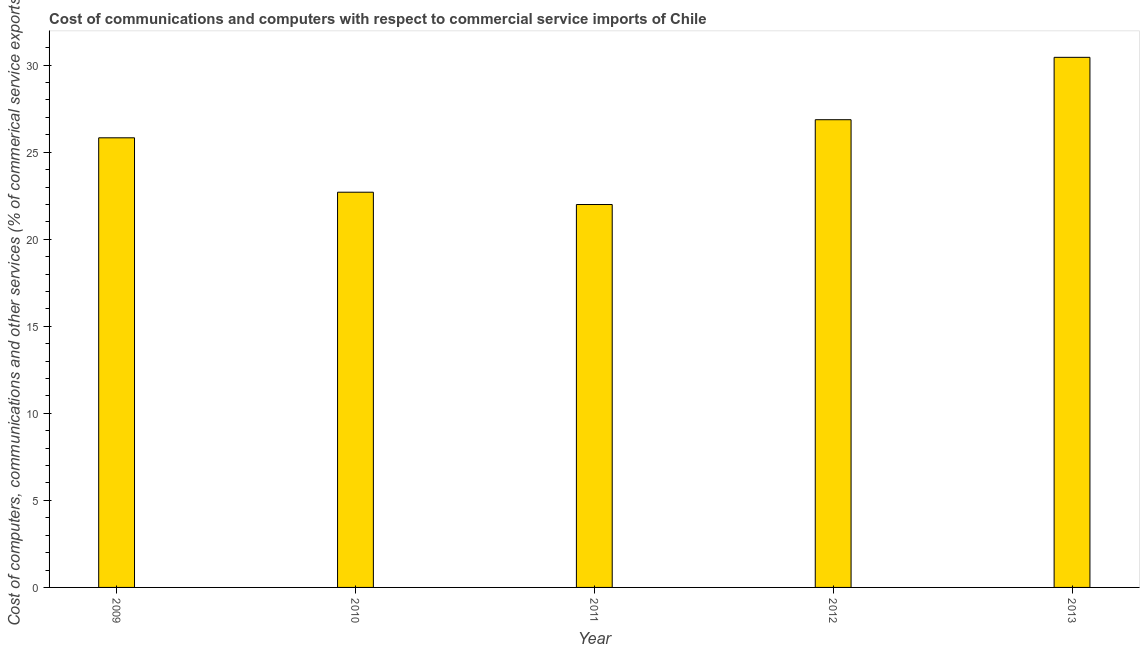Does the graph contain any zero values?
Provide a short and direct response. No. What is the title of the graph?
Ensure brevity in your answer.  Cost of communications and computers with respect to commercial service imports of Chile. What is the label or title of the Y-axis?
Keep it short and to the point. Cost of computers, communications and other services (% of commerical service exports). What is the cost of communications in 2013?
Ensure brevity in your answer.  30.45. Across all years, what is the maximum  computer and other services?
Offer a very short reply. 30.45. Across all years, what is the minimum  computer and other services?
Offer a very short reply. 21.99. In which year was the cost of communications minimum?
Provide a short and direct response. 2011. What is the sum of the  computer and other services?
Offer a terse response. 127.83. What is the difference between the  computer and other services in 2009 and 2012?
Keep it short and to the point. -1.04. What is the average  computer and other services per year?
Provide a short and direct response. 25.57. What is the median  computer and other services?
Provide a succinct answer. 25.83. Do a majority of the years between 2009 and 2010 (inclusive) have cost of communications greater than 26 %?
Ensure brevity in your answer.  No. What is the ratio of the  computer and other services in 2009 to that in 2013?
Provide a short and direct response. 0.85. Is the  computer and other services in 2010 less than that in 2012?
Your answer should be compact. Yes. Is the difference between the cost of communications in 2009 and 2010 greater than the difference between any two years?
Your response must be concise. No. What is the difference between the highest and the second highest  computer and other services?
Ensure brevity in your answer.  3.58. Is the sum of the cost of communications in 2010 and 2011 greater than the maximum cost of communications across all years?
Provide a succinct answer. Yes. What is the difference between the highest and the lowest cost of communications?
Your answer should be compact. 8.45. How many bars are there?
Provide a short and direct response. 5. Are all the bars in the graph horizontal?
Provide a succinct answer. No. How many years are there in the graph?
Make the answer very short. 5. What is the Cost of computers, communications and other services (% of commerical service exports) in 2009?
Provide a short and direct response. 25.83. What is the Cost of computers, communications and other services (% of commerical service exports) of 2010?
Your response must be concise. 22.7. What is the Cost of computers, communications and other services (% of commerical service exports) of 2011?
Offer a terse response. 21.99. What is the Cost of computers, communications and other services (% of commerical service exports) in 2012?
Provide a short and direct response. 26.87. What is the Cost of computers, communications and other services (% of commerical service exports) in 2013?
Give a very brief answer. 30.45. What is the difference between the Cost of computers, communications and other services (% of commerical service exports) in 2009 and 2010?
Provide a succinct answer. 3.12. What is the difference between the Cost of computers, communications and other services (% of commerical service exports) in 2009 and 2011?
Provide a succinct answer. 3.83. What is the difference between the Cost of computers, communications and other services (% of commerical service exports) in 2009 and 2012?
Give a very brief answer. -1.04. What is the difference between the Cost of computers, communications and other services (% of commerical service exports) in 2009 and 2013?
Your response must be concise. -4.62. What is the difference between the Cost of computers, communications and other services (% of commerical service exports) in 2010 and 2011?
Your answer should be compact. 0.71. What is the difference between the Cost of computers, communications and other services (% of commerical service exports) in 2010 and 2012?
Keep it short and to the point. -4.16. What is the difference between the Cost of computers, communications and other services (% of commerical service exports) in 2010 and 2013?
Provide a succinct answer. -7.75. What is the difference between the Cost of computers, communications and other services (% of commerical service exports) in 2011 and 2012?
Provide a succinct answer. -4.87. What is the difference between the Cost of computers, communications and other services (% of commerical service exports) in 2011 and 2013?
Your answer should be very brief. -8.45. What is the difference between the Cost of computers, communications and other services (% of commerical service exports) in 2012 and 2013?
Provide a succinct answer. -3.58. What is the ratio of the Cost of computers, communications and other services (% of commerical service exports) in 2009 to that in 2010?
Provide a short and direct response. 1.14. What is the ratio of the Cost of computers, communications and other services (% of commerical service exports) in 2009 to that in 2011?
Provide a short and direct response. 1.17. What is the ratio of the Cost of computers, communications and other services (% of commerical service exports) in 2009 to that in 2012?
Provide a succinct answer. 0.96. What is the ratio of the Cost of computers, communications and other services (% of commerical service exports) in 2009 to that in 2013?
Your response must be concise. 0.85. What is the ratio of the Cost of computers, communications and other services (% of commerical service exports) in 2010 to that in 2011?
Keep it short and to the point. 1.03. What is the ratio of the Cost of computers, communications and other services (% of commerical service exports) in 2010 to that in 2012?
Ensure brevity in your answer.  0.84. What is the ratio of the Cost of computers, communications and other services (% of commerical service exports) in 2010 to that in 2013?
Make the answer very short. 0.75. What is the ratio of the Cost of computers, communications and other services (% of commerical service exports) in 2011 to that in 2012?
Offer a very short reply. 0.82. What is the ratio of the Cost of computers, communications and other services (% of commerical service exports) in 2011 to that in 2013?
Provide a short and direct response. 0.72. What is the ratio of the Cost of computers, communications and other services (% of commerical service exports) in 2012 to that in 2013?
Give a very brief answer. 0.88. 